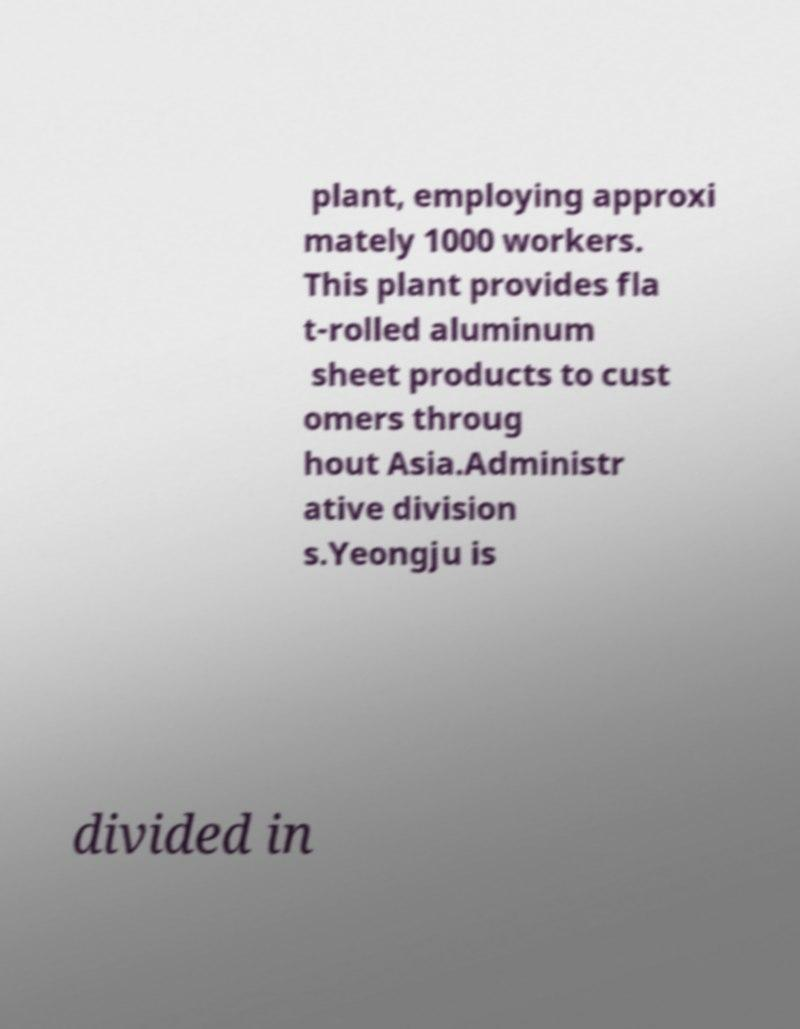Could you assist in decoding the text presented in this image and type it out clearly? plant, employing approxi mately 1000 workers. This plant provides fla t-rolled aluminum sheet products to cust omers throug hout Asia.Administr ative division s.Yeongju is divided in 